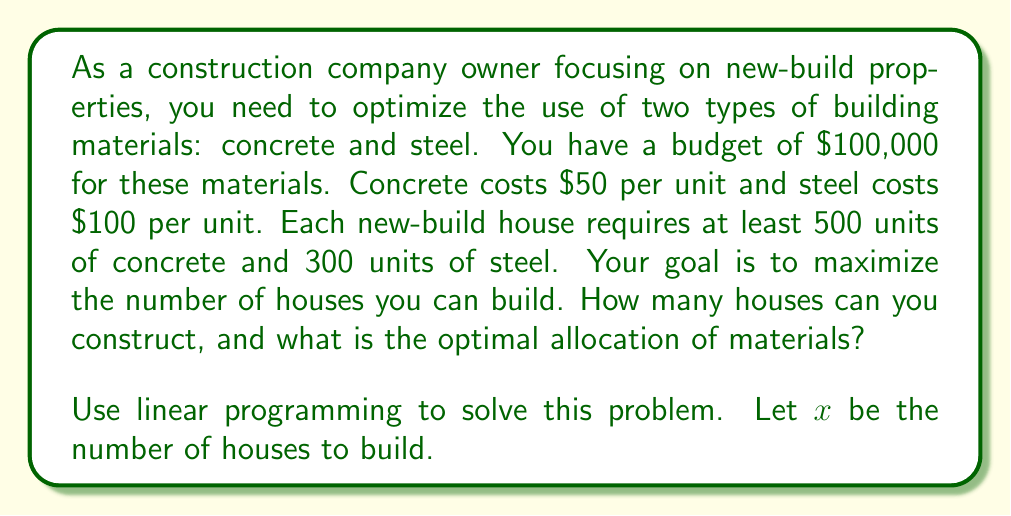Show me your answer to this math problem. Let's approach this step-by-step using linear programming:

1) Define variables:
   $x$ = number of houses to build
   $c$ = units of concrete per house
   $s$ = units of steel per house

2) Objective function:
   Maximize $x$

3) Constraints:
   a) Concrete constraint: $50c \leq 100000$ (cost of concrete ≤ budget)
   b) Steel constraint: $100s \leq 100000$ (cost of steel ≤ budget)
   c) House requirements: $c \geq 500x$ and $s \geq 300x$
   d) Non-negativity: $x, c, s \geq 0$

4) Combining constraints:
   $50(500x) + 100(300x) \leq 100000$
   $25000x + 30000x \leq 100000$
   $55000x \leq 100000$

5) Solving for x:
   $x \leq \frac{100000}{55000} = \frac{20}{11} \approx 1.82$

6) Since we can't build a fraction of a house, we round down to 1 house.

7) Optimal allocation:
   Concrete: 500 units
   Steel: 300 units

This allocation uses $50(500) + 100(300) = 55000$ of the budget, which is the most efficient use given the constraints.
Answer: 1 house; 500 units of concrete and 300 units of steel 